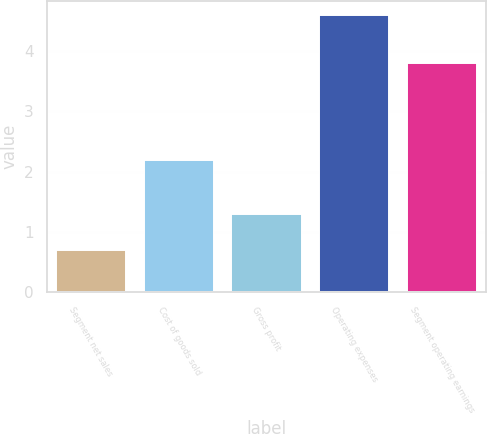<chart> <loc_0><loc_0><loc_500><loc_500><bar_chart><fcel>Segment net sales<fcel>Cost of goods sold<fcel>Gross profit<fcel>Operating expenses<fcel>Segment operating earnings<nl><fcel>0.7<fcel>2.2<fcel>1.3<fcel>4.6<fcel>3.8<nl></chart> 